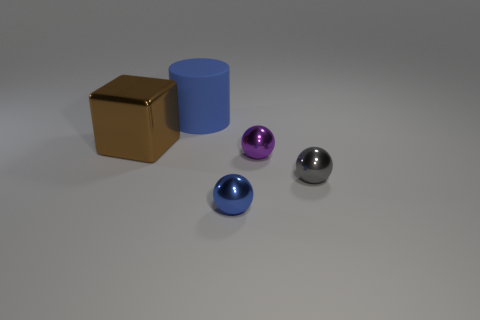What number of small gray objects have the same material as the big blue cylinder?
Provide a succinct answer. 0. What color is the big object behind the brown metallic block left of the big thing behind the cube?
Make the answer very short. Blue. Is the size of the gray sphere the same as the block?
Ensure brevity in your answer.  No. Is there anything else that is the same shape as the large blue rubber thing?
Make the answer very short. No. How many objects are either objects that are to the right of the large block or metallic spheres?
Your response must be concise. 4. Does the tiny gray shiny object have the same shape as the purple metallic object?
Your answer should be compact. Yes. How many other things are the same size as the purple ball?
Your response must be concise. 2. What is the color of the matte cylinder?
Make the answer very short. Blue. How many small objects are purple things or brown shiny objects?
Your answer should be very brief. 1. Does the thing in front of the tiny gray sphere have the same size as the blue thing that is behind the gray thing?
Your response must be concise. No. 